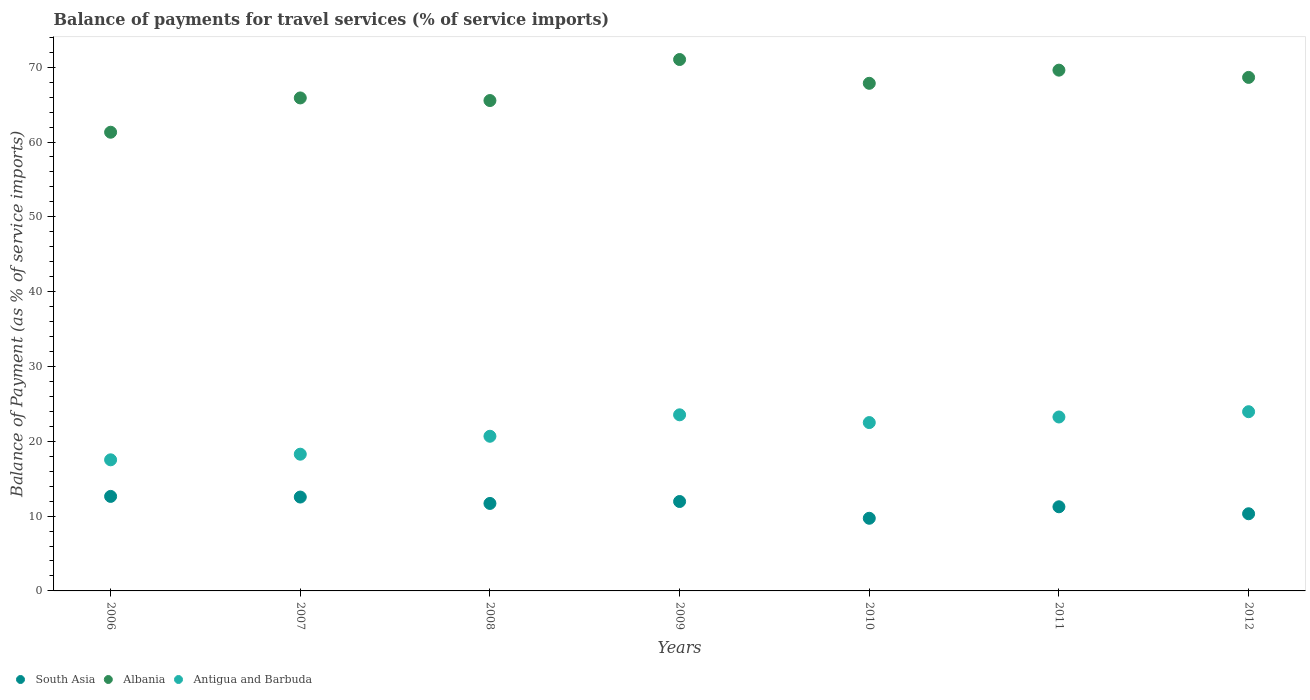How many different coloured dotlines are there?
Give a very brief answer. 3. Is the number of dotlines equal to the number of legend labels?
Your response must be concise. Yes. What is the balance of payments for travel services in Albania in 2008?
Ensure brevity in your answer.  65.54. Across all years, what is the maximum balance of payments for travel services in South Asia?
Give a very brief answer. 12.63. Across all years, what is the minimum balance of payments for travel services in Albania?
Ensure brevity in your answer.  61.31. In which year was the balance of payments for travel services in South Asia maximum?
Your answer should be very brief. 2006. In which year was the balance of payments for travel services in South Asia minimum?
Provide a succinct answer. 2010. What is the total balance of payments for travel services in Albania in the graph?
Provide a succinct answer. 469.87. What is the difference between the balance of payments for travel services in South Asia in 2010 and that in 2012?
Make the answer very short. -0.6. What is the difference between the balance of payments for travel services in South Asia in 2012 and the balance of payments for travel services in Antigua and Barbuda in 2009?
Offer a very short reply. -13.22. What is the average balance of payments for travel services in Antigua and Barbuda per year?
Ensure brevity in your answer.  21.39. In the year 2007, what is the difference between the balance of payments for travel services in Antigua and Barbuda and balance of payments for travel services in South Asia?
Provide a succinct answer. 5.73. In how many years, is the balance of payments for travel services in Albania greater than 66 %?
Provide a short and direct response. 4. What is the ratio of the balance of payments for travel services in Antigua and Barbuda in 2008 to that in 2011?
Provide a succinct answer. 0.89. Is the balance of payments for travel services in Albania in 2009 less than that in 2010?
Give a very brief answer. No. Is the difference between the balance of payments for travel services in Antigua and Barbuda in 2008 and 2012 greater than the difference between the balance of payments for travel services in South Asia in 2008 and 2012?
Ensure brevity in your answer.  No. What is the difference between the highest and the second highest balance of payments for travel services in Antigua and Barbuda?
Ensure brevity in your answer.  0.42. What is the difference between the highest and the lowest balance of payments for travel services in Albania?
Give a very brief answer. 9.72. In how many years, is the balance of payments for travel services in Albania greater than the average balance of payments for travel services in Albania taken over all years?
Your answer should be compact. 4. Is the balance of payments for travel services in South Asia strictly greater than the balance of payments for travel services in Antigua and Barbuda over the years?
Keep it short and to the point. No. Is the balance of payments for travel services in South Asia strictly less than the balance of payments for travel services in Albania over the years?
Offer a very short reply. Yes. How many dotlines are there?
Your answer should be very brief. 3. How many years are there in the graph?
Your response must be concise. 7. What is the difference between two consecutive major ticks on the Y-axis?
Give a very brief answer. 10. Does the graph contain any zero values?
Make the answer very short. No. Does the graph contain grids?
Keep it short and to the point. No. How many legend labels are there?
Offer a very short reply. 3. What is the title of the graph?
Offer a very short reply. Balance of payments for travel services (% of service imports). Does "Saudi Arabia" appear as one of the legend labels in the graph?
Your response must be concise. No. What is the label or title of the Y-axis?
Make the answer very short. Balance of Payment (as % of service imports). What is the Balance of Payment (as % of service imports) of South Asia in 2006?
Offer a terse response. 12.63. What is the Balance of Payment (as % of service imports) in Albania in 2006?
Give a very brief answer. 61.31. What is the Balance of Payment (as % of service imports) in Antigua and Barbuda in 2006?
Provide a short and direct response. 17.52. What is the Balance of Payment (as % of service imports) of South Asia in 2007?
Provide a succinct answer. 12.55. What is the Balance of Payment (as % of service imports) in Albania in 2007?
Ensure brevity in your answer.  65.89. What is the Balance of Payment (as % of service imports) in Antigua and Barbuda in 2007?
Offer a very short reply. 18.27. What is the Balance of Payment (as % of service imports) in South Asia in 2008?
Provide a succinct answer. 11.69. What is the Balance of Payment (as % of service imports) of Albania in 2008?
Give a very brief answer. 65.54. What is the Balance of Payment (as % of service imports) in Antigua and Barbuda in 2008?
Your answer should be very brief. 20.67. What is the Balance of Payment (as % of service imports) in South Asia in 2009?
Your answer should be very brief. 11.95. What is the Balance of Payment (as % of service imports) of Albania in 2009?
Your answer should be compact. 71.03. What is the Balance of Payment (as % of service imports) of Antigua and Barbuda in 2009?
Your answer should be compact. 23.54. What is the Balance of Payment (as % of service imports) of South Asia in 2010?
Provide a succinct answer. 9.71. What is the Balance of Payment (as % of service imports) of Albania in 2010?
Your answer should be very brief. 67.85. What is the Balance of Payment (as % of service imports) in Antigua and Barbuda in 2010?
Your response must be concise. 22.5. What is the Balance of Payment (as % of service imports) in South Asia in 2011?
Offer a very short reply. 11.25. What is the Balance of Payment (as % of service imports) in Albania in 2011?
Provide a succinct answer. 69.61. What is the Balance of Payment (as % of service imports) in Antigua and Barbuda in 2011?
Make the answer very short. 23.25. What is the Balance of Payment (as % of service imports) of South Asia in 2012?
Your answer should be compact. 10.31. What is the Balance of Payment (as % of service imports) in Albania in 2012?
Make the answer very short. 68.64. What is the Balance of Payment (as % of service imports) of Antigua and Barbuda in 2012?
Provide a succinct answer. 23.95. Across all years, what is the maximum Balance of Payment (as % of service imports) in South Asia?
Your answer should be very brief. 12.63. Across all years, what is the maximum Balance of Payment (as % of service imports) in Albania?
Give a very brief answer. 71.03. Across all years, what is the maximum Balance of Payment (as % of service imports) in Antigua and Barbuda?
Your response must be concise. 23.95. Across all years, what is the minimum Balance of Payment (as % of service imports) in South Asia?
Your response must be concise. 9.71. Across all years, what is the minimum Balance of Payment (as % of service imports) of Albania?
Make the answer very short. 61.31. Across all years, what is the minimum Balance of Payment (as % of service imports) in Antigua and Barbuda?
Offer a very short reply. 17.52. What is the total Balance of Payment (as % of service imports) of South Asia in the graph?
Your answer should be compact. 80.1. What is the total Balance of Payment (as % of service imports) of Albania in the graph?
Keep it short and to the point. 469.87. What is the total Balance of Payment (as % of service imports) of Antigua and Barbuda in the graph?
Offer a very short reply. 149.71. What is the difference between the Balance of Payment (as % of service imports) of South Asia in 2006 and that in 2007?
Your answer should be compact. 0.09. What is the difference between the Balance of Payment (as % of service imports) in Albania in 2006 and that in 2007?
Keep it short and to the point. -4.58. What is the difference between the Balance of Payment (as % of service imports) in Antigua and Barbuda in 2006 and that in 2007?
Make the answer very short. -0.75. What is the difference between the Balance of Payment (as % of service imports) of South Asia in 2006 and that in 2008?
Give a very brief answer. 0.94. What is the difference between the Balance of Payment (as % of service imports) in Albania in 2006 and that in 2008?
Provide a short and direct response. -4.24. What is the difference between the Balance of Payment (as % of service imports) in Antigua and Barbuda in 2006 and that in 2008?
Make the answer very short. -3.15. What is the difference between the Balance of Payment (as % of service imports) in South Asia in 2006 and that in 2009?
Your answer should be compact. 0.68. What is the difference between the Balance of Payment (as % of service imports) in Albania in 2006 and that in 2009?
Your answer should be very brief. -9.72. What is the difference between the Balance of Payment (as % of service imports) in Antigua and Barbuda in 2006 and that in 2009?
Make the answer very short. -6.01. What is the difference between the Balance of Payment (as % of service imports) of South Asia in 2006 and that in 2010?
Give a very brief answer. 2.92. What is the difference between the Balance of Payment (as % of service imports) in Albania in 2006 and that in 2010?
Make the answer very short. -6.54. What is the difference between the Balance of Payment (as % of service imports) of Antigua and Barbuda in 2006 and that in 2010?
Keep it short and to the point. -4.98. What is the difference between the Balance of Payment (as % of service imports) in South Asia in 2006 and that in 2011?
Provide a short and direct response. 1.39. What is the difference between the Balance of Payment (as % of service imports) in Albania in 2006 and that in 2011?
Offer a very short reply. -8.3. What is the difference between the Balance of Payment (as % of service imports) of Antigua and Barbuda in 2006 and that in 2011?
Provide a short and direct response. -5.72. What is the difference between the Balance of Payment (as % of service imports) in South Asia in 2006 and that in 2012?
Your answer should be compact. 2.32. What is the difference between the Balance of Payment (as % of service imports) of Albania in 2006 and that in 2012?
Your answer should be compact. -7.33. What is the difference between the Balance of Payment (as % of service imports) in Antigua and Barbuda in 2006 and that in 2012?
Your answer should be compact. -6.43. What is the difference between the Balance of Payment (as % of service imports) of South Asia in 2007 and that in 2008?
Offer a very short reply. 0.85. What is the difference between the Balance of Payment (as % of service imports) of Albania in 2007 and that in 2008?
Offer a very short reply. 0.35. What is the difference between the Balance of Payment (as % of service imports) of Antigua and Barbuda in 2007 and that in 2008?
Provide a short and direct response. -2.4. What is the difference between the Balance of Payment (as % of service imports) in South Asia in 2007 and that in 2009?
Provide a succinct answer. 0.6. What is the difference between the Balance of Payment (as % of service imports) in Albania in 2007 and that in 2009?
Ensure brevity in your answer.  -5.14. What is the difference between the Balance of Payment (as % of service imports) in Antigua and Barbuda in 2007 and that in 2009?
Provide a succinct answer. -5.26. What is the difference between the Balance of Payment (as % of service imports) of South Asia in 2007 and that in 2010?
Ensure brevity in your answer.  2.84. What is the difference between the Balance of Payment (as % of service imports) of Albania in 2007 and that in 2010?
Your answer should be compact. -1.96. What is the difference between the Balance of Payment (as % of service imports) of Antigua and Barbuda in 2007 and that in 2010?
Keep it short and to the point. -4.23. What is the difference between the Balance of Payment (as % of service imports) of South Asia in 2007 and that in 2011?
Offer a very short reply. 1.3. What is the difference between the Balance of Payment (as % of service imports) of Albania in 2007 and that in 2011?
Keep it short and to the point. -3.71. What is the difference between the Balance of Payment (as % of service imports) of Antigua and Barbuda in 2007 and that in 2011?
Give a very brief answer. -4.97. What is the difference between the Balance of Payment (as % of service imports) of South Asia in 2007 and that in 2012?
Provide a succinct answer. 2.23. What is the difference between the Balance of Payment (as % of service imports) of Albania in 2007 and that in 2012?
Your response must be concise. -2.75. What is the difference between the Balance of Payment (as % of service imports) in Antigua and Barbuda in 2007 and that in 2012?
Keep it short and to the point. -5.68. What is the difference between the Balance of Payment (as % of service imports) in South Asia in 2008 and that in 2009?
Offer a very short reply. -0.26. What is the difference between the Balance of Payment (as % of service imports) in Albania in 2008 and that in 2009?
Your answer should be compact. -5.48. What is the difference between the Balance of Payment (as % of service imports) in Antigua and Barbuda in 2008 and that in 2009?
Your answer should be very brief. -2.87. What is the difference between the Balance of Payment (as % of service imports) in South Asia in 2008 and that in 2010?
Keep it short and to the point. 1.98. What is the difference between the Balance of Payment (as % of service imports) in Albania in 2008 and that in 2010?
Give a very brief answer. -2.3. What is the difference between the Balance of Payment (as % of service imports) in Antigua and Barbuda in 2008 and that in 2010?
Make the answer very short. -1.83. What is the difference between the Balance of Payment (as % of service imports) in South Asia in 2008 and that in 2011?
Give a very brief answer. 0.45. What is the difference between the Balance of Payment (as % of service imports) in Albania in 2008 and that in 2011?
Offer a very short reply. -4.06. What is the difference between the Balance of Payment (as % of service imports) in Antigua and Barbuda in 2008 and that in 2011?
Offer a very short reply. -2.58. What is the difference between the Balance of Payment (as % of service imports) of South Asia in 2008 and that in 2012?
Give a very brief answer. 1.38. What is the difference between the Balance of Payment (as % of service imports) in Albania in 2008 and that in 2012?
Give a very brief answer. -3.09. What is the difference between the Balance of Payment (as % of service imports) in Antigua and Barbuda in 2008 and that in 2012?
Your answer should be compact. -3.28. What is the difference between the Balance of Payment (as % of service imports) of South Asia in 2009 and that in 2010?
Your response must be concise. 2.24. What is the difference between the Balance of Payment (as % of service imports) of Albania in 2009 and that in 2010?
Ensure brevity in your answer.  3.18. What is the difference between the Balance of Payment (as % of service imports) in Antigua and Barbuda in 2009 and that in 2010?
Your response must be concise. 1.04. What is the difference between the Balance of Payment (as % of service imports) of South Asia in 2009 and that in 2011?
Provide a succinct answer. 0.71. What is the difference between the Balance of Payment (as % of service imports) in Albania in 2009 and that in 2011?
Keep it short and to the point. 1.42. What is the difference between the Balance of Payment (as % of service imports) of Antigua and Barbuda in 2009 and that in 2011?
Provide a short and direct response. 0.29. What is the difference between the Balance of Payment (as % of service imports) in South Asia in 2009 and that in 2012?
Make the answer very short. 1.64. What is the difference between the Balance of Payment (as % of service imports) in Albania in 2009 and that in 2012?
Offer a very short reply. 2.39. What is the difference between the Balance of Payment (as % of service imports) in Antigua and Barbuda in 2009 and that in 2012?
Provide a short and direct response. -0.42. What is the difference between the Balance of Payment (as % of service imports) in South Asia in 2010 and that in 2011?
Your answer should be very brief. -1.54. What is the difference between the Balance of Payment (as % of service imports) of Albania in 2010 and that in 2011?
Provide a succinct answer. -1.76. What is the difference between the Balance of Payment (as % of service imports) of Antigua and Barbuda in 2010 and that in 2011?
Keep it short and to the point. -0.75. What is the difference between the Balance of Payment (as % of service imports) in South Asia in 2010 and that in 2012?
Your answer should be very brief. -0.6. What is the difference between the Balance of Payment (as % of service imports) of Albania in 2010 and that in 2012?
Provide a short and direct response. -0.79. What is the difference between the Balance of Payment (as % of service imports) of Antigua and Barbuda in 2010 and that in 2012?
Provide a short and direct response. -1.45. What is the difference between the Balance of Payment (as % of service imports) in South Asia in 2011 and that in 2012?
Keep it short and to the point. 0.93. What is the difference between the Balance of Payment (as % of service imports) of Albania in 2011 and that in 2012?
Make the answer very short. 0.97. What is the difference between the Balance of Payment (as % of service imports) in Antigua and Barbuda in 2011 and that in 2012?
Make the answer very short. -0.71. What is the difference between the Balance of Payment (as % of service imports) of South Asia in 2006 and the Balance of Payment (as % of service imports) of Albania in 2007?
Ensure brevity in your answer.  -53.26. What is the difference between the Balance of Payment (as % of service imports) of South Asia in 2006 and the Balance of Payment (as % of service imports) of Antigua and Barbuda in 2007?
Offer a terse response. -5.64. What is the difference between the Balance of Payment (as % of service imports) in Albania in 2006 and the Balance of Payment (as % of service imports) in Antigua and Barbuda in 2007?
Ensure brevity in your answer.  43.03. What is the difference between the Balance of Payment (as % of service imports) in South Asia in 2006 and the Balance of Payment (as % of service imports) in Albania in 2008?
Your answer should be very brief. -52.91. What is the difference between the Balance of Payment (as % of service imports) in South Asia in 2006 and the Balance of Payment (as % of service imports) in Antigua and Barbuda in 2008?
Make the answer very short. -8.04. What is the difference between the Balance of Payment (as % of service imports) of Albania in 2006 and the Balance of Payment (as % of service imports) of Antigua and Barbuda in 2008?
Give a very brief answer. 40.64. What is the difference between the Balance of Payment (as % of service imports) of South Asia in 2006 and the Balance of Payment (as % of service imports) of Albania in 2009?
Offer a terse response. -58.4. What is the difference between the Balance of Payment (as % of service imports) in South Asia in 2006 and the Balance of Payment (as % of service imports) in Antigua and Barbuda in 2009?
Your response must be concise. -10.91. What is the difference between the Balance of Payment (as % of service imports) of Albania in 2006 and the Balance of Payment (as % of service imports) of Antigua and Barbuda in 2009?
Give a very brief answer. 37.77. What is the difference between the Balance of Payment (as % of service imports) in South Asia in 2006 and the Balance of Payment (as % of service imports) in Albania in 2010?
Your answer should be compact. -55.21. What is the difference between the Balance of Payment (as % of service imports) of South Asia in 2006 and the Balance of Payment (as % of service imports) of Antigua and Barbuda in 2010?
Your answer should be very brief. -9.87. What is the difference between the Balance of Payment (as % of service imports) in Albania in 2006 and the Balance of Payment (as % of service imports) in Antigua and Barbuda in 2010?
Give a very brief answer. 38.81. What is the difference between the Balance of Payment (as % of service imports) of South Asia in 2006 and the Balance of Payment (as % of service imports) of Albania in 2011?
Your answer should be compact. -56.97. What is the difference between the Balance of Payment (as % of service imports) of South Asia in 2006 and the Balance of Payment (as % of service imports) of Antigua and Barbuda in 2011?
Your response must be concise. -10.61. What is the difference between the Balance of Payment (as % of service imports) in Albania in 2006 and the Balance of Payment (as % of service imports) in Antigua and Barbuda in 2011?
Offer a very short reply. 38.06. What is the difference between the Balance of Payment (as % of service imports) in South Asia in 2006 and the Balance of Payment (as % of service imports) in Albania in 2012?
Offer a very short reply. -56. What is the difference between the Balance of Payment (as % of service imports) of South Asia in 2006 and the Balance of Payment (as % of service imports) of Antigua and Barbuda in 2012?
Offer a terse response. -11.32. What is the difference between the Balance of Payment (as % of service imports) of Albania in 2006 and the Balance of Payment (as % of service imports) of Antigua and Barbuda in 2012?
Give a very brief answer. 37.35. What is the difference between the Balance of Payment (as % of service imports) in South Asia in 2007 and the Balance of Payment (as % of service imports) in Albania in 2008?
Your answer should be compact. -53. What is the difference between the Balance of Payment (as % of service imports) in South Asia in 2007 and the Balance of Payment (as % of service imports) in Antigua and Barbuda in 2008?
Your answer should be very brief. -8.13. What is the difference between the Balance of Payment (as % of service imports) in Albania in 2007 and the Balance of Payment (as % of service imports) in Antigua and Barbuda in 2008?
Offer a very short reply. 45.22. What is the difference between the Balance of Payment (as % of service imports) of South Asia in 2007 and the Balance of Payment (as % of service imports) of Albania in 2009?
Provide a succinct answer. -58.48. What is the difference between the Balance of Payment (as % of service imports) in South Asia in 2007 and the Balance of Payment (as % of service imports) in Antigua and Barbuda in 2009?
Your answer should be very brief. -10.99. What is the difference between the Balance of Payment (as % of service imports) of Albania in 2007 and the Balance of Payment (as % of service imports) of Antigua and Barbuda in 2009?
Offer a very short reply. 42.35. What is the difference between the Balance of Payment (as % of service imports) of South Asia in 2007 and the Balance of Payment (as % of service imports) of Albania in 2010?
Your response must be concise. -55.3. What is the difference between the Balance of Payment (as % of service imports) of South Asia in 2007 and the Balance of Payment (as % of service imports) of Antigua and Barbuda in 2010?
Ensure brevity in your answer.  -9.95. What is the difference between the Balance of Payment (as % of service imports) of Albania in 2007 and the Balance of Payment (as % of service imports) of Antigua and Barbuda in 2010?
Your answer should be compact. 43.39. What is the difference between the Balance of Payment (as % of service imports) of South Asia in 2007 and the Balance of Payment (as % of service imports) of Albania in 2011?
Offer a terse response. -57.06. What is the difference between the Balance of Payment (as % of service imports) in South Asia in 2007 and the Balance of Payment (as % of service imports) in Antigua and Barbuda in 2011?
Give a very brief answer. -10.7. What is the difference between the Balance of Payment (as % of service imports) of Albania in 2007 and the Balance of Payment (as % of service imports) of Antigua and Barbuda in 2011?
Provide a short and direct response. 42.64. What is the difference between the Balance of Payment (as % of service imports) of South Asia in 2007 and the Balance of Payment (as % of service imports) of Albania in 2012?
Keep it short and to the point. -56.09. What is the difference between the Balance of Payment (as % of service imports) in South Asia in 2007 and the Balance of Payment (as % of service imports) in Antigua and Barbuda in 2012?
Your response must be concise. -11.41. What is the difference between the Balance of Payment (as % of service imports) in Albania in 2007 and the Balance of Payment (as % of service imports) in Antigua and Barbuda in 2012?
Provide a succinct answer. 41.94. What is the difference between the Balance of Payment (as % of service imports) in South Asia in 2008 and the Balance of Payment (as % of service imports) in Albania in 2009?
Give a very brief answer. -59.34. What is the difference between the Balance of Payment (as % of service imports) of South Asia in 2008 and the Balance of Payment (as % of service imports) of Antigua and Barbuda in 2009?
Your response must be concise. -11.85. What is the difference between the Balance of Payment (as % of service imports) in Albania in 2008 and the Balance of Payment (as % of service imports) in Antigua and Barbuda in 2009?
Your answer should be compact. 42.01. What is the difference between the Balance of Payment (as % of service imports) of South Asia in 2008 and the Balance of Payment (as % of service imports) of Albania in 2010?
Provide a short and direct response. -56.15. What is the difference between the Balance of Payment (as % of service imports) in South Asia in 2008 and the Balance of Payment (as % of service imports) in Antigua and Barbuda in 2010?
Keep it short and to the point. -10.81. What is the difference between the Balance of Payment (as % of service imports) in Albania in 2008 and the Balance of Payment (as % of service imports) in Antigua and Barbuda in 2010?
Your answer should be compact. 43.04. What is the difference between the Balance of Payment (as % of service imports) in South Asia in 2008 and the Balance of Payment (as % of service imports) in Albania in 2011?
Your answer should be compact. -57.91. What is the difference between the Balance of Payment (as % of service imports) in South Asia in 2008 and the Balance of Payment (as % of service imports) in Antigua and Barbuda in 2011?
Your answer should be compact. -11.55. What is the difference between the Balance of Payment (as % of service imports) in Albania in 2008 and the Balance of Payment (as % of service imports) in Antigua and Barbuda in 2011?
Provide a short and direct response. 42.3. What is the difference between the Balance of Payment (as % of service imports) in South Asia in 2008 and the Balance of Payment (as % of service imports) in Albania in 2012?
Provide a succinct answer. -56.94. What is the difference between the Balance of Payment (as % of service imports) of South Asia in 2008 and the Balance of Payment (as % of service imports) of Antigua and Barbuda in 2012?
Your response must be concise. -12.26. What is the difference between the Balance of Payment (as % of service imports) of Albania in 2008 and the Balance of Payment (as % of service imports) of Antigua and Barbuda in 2012?
Provide a succinct answer. 41.59. What is the difference between the Balance of Payment (as % of service imports) in South Asia in 2009 and the Balance of Payment (as % of service imports) in Albania in 2010?
Offer a very short reply. -55.9. What is the difference between the Balance of Payment (as % of service imports) in South Asia in 2009 and the Balance of Payment (as % of service imports) in Antigua and Barbuda in 2010?
Your response must be concise. -10.55. What is the difference between the Balance of Payment (as % of service imports) in Albania in 2009 and the Balance of Payment (as % of service imports) in Antigua and Barbuda in 2010?
Your response must be concise. 48.53. What is the difference between the Balance of Payment (as % of service imports) of South Asia in 2009 and the Balance of Payment (as % of service imports) of Albania in 2011?
Offer a terse response. -57.65. What is the difference between the Balance of Payment (as % of service imports) in South Asia in 2009 and the Balance of Payment (as % of service imports) in Antigua and Barbuda in 2011?
Ensure brevity in your answer.  -11.3. What is the difference between the Balance of Payment (as % of service imports) of Albania in 2009 and the Balance of Payment (as % of service imports) of Antigua and Barbuda in 2011?
Offer a very short reply. 47.78. What is the difference between the Balance of Payment (as % of service imports) of South Asia in 2009 and the Balance of Payment (as % of service imports) of Albania in 2012?
Give a very brief answer. -56.69. What is the difference between the Balance of Payment (as % of service imports) of South Asia in 2009 and the Balance of Payment (as % of service imports) of Antigua and Barbuda in 2012?
Keep it short and to the point. -12. What is the difference between the Balance of Payment (as % of service imports) of Albania in 2009 and the Balance of Payment (as % of service imports) of Antigua and Barbuda in 2012?
Make the answer very short. 47.07. What is the difference between the Balance of Payment (as % of service imports) of South Asia in 2010 and the Balance of Payment (as % of service imports) of Albania in 2011?
Ensure brevity in your answer.  -59.9. What is the difference between the Balance of Payment (as % of service imports) of South Asia in 2010 and the Balance of Payment (as % of service imports) of Antigua and Barbuda in 2011?
Give a very brief answer. -13.54. What is the difference between the Balance of Payment (as % of service imports) of Albania in 2010 and the Balance of Payment (as % of service imports) of Antigua and Barbuda in 2011?
Provide a succinct answer. 44.6. What is the difference between the Balance of Payment (as % of service imports) of South Asia in 2010 and the Balance of Payment (as % of service imports) of Albania in 2012?
Keep it short and to the point. -58.93. What is the difference between the Balance of Payment (as % of service imports) in South Asia in 2010 and the Balance of Payment (as % of service imports) in Antigua and Barbuda in 2012?
Offer a very short reply. -14.24. What is the difference between the Balance of Payment (as % of service imports) in Albania in 2010 and the Balance of Payment (as % of service imports) in Antigua and Barbuda in 2012?
Offer a terse response. 43.89. What is the difference between the Balance of Payment (as % of service imports) of South Asia in 2011 and the Balance of Payment (as % of service imports) of Albania in 2012?
Provide a succinct answer. -57.39. What is the difference between the Balance of Payment (as % of service imports) in South Asia in 2011 and the Balance of Payment (as % of service imports) in Antigua and Barbuda in 2012?
Provide a short and direct response. -12.71. What is the difference between the Balance of Payment (as % of service imports) of Albania in 2011 and the Balance of Payment (as % of service imports) of Antigua and Barbuda in 2012?
Ensure brevity in your answer.  45.65. What is the average Balance of Payment (as % of service imports) of South Asia per year?
Offer a terse response. 11.44. What is the average Balance of Payment (as % of service imports) of Albania per year?
Make the answer very short. 67.12. What is the average Balance of Payment (as % of service imports) in Antigua and Barbuda per year?
Provide a succinct answer. 21.39. In the year 2006, what is the difference between the Balance of Payment (as % of service imports) in South Asia and Balance of Payment (as % of service imports) in Albania?
Offer a very short reply. -48.68. In the year 2006, what is the difference between the Balance of Payment (as % of service imports) in South Asia and Balance of Payment (as % of service imports) in Antigua and Barbuda?
Your response must be concise. -4.89. In the year 2006, what is the difference between the Balance of Payment (as % of service imports) in Albania and Balance of Payment (as % of service imports) in Antigua and Barbuda?
Your answer should be very brief. 43.78. In the year 2007, what is the difference between the Balance of Payment (as % of service imports) in South Asia and Balance of Payment (as % of service imports) in Albania?
Ensure brevity in your answer.  -53.35. In the year 2007, what is the difference between the Balance of Payment (as % of service imports) in South Asia and Balance of Payment (as % of service imports) in Antigua and Barbuda?
Give a very brief answer. -5.73. In the year 2007, what is the difference between the Balance of Payment (as % of service imports) in Albania and Balance of Payment (as % of service imports) in Antigua and Barbuda?
Provide a succinct answer. 47.62. In the year 2008, what is the difference between the Balance of Payment (as % of service imports) of South Asia and Balance of Payment (as % of service imports) of Albania?
Your response must be concise. -53.85. In the year 2008, what is the difference between the Balance of Payment (as % of service imports) in South Asia and Balance of Payment (as % of service imports) in Antigua and Barbuda?
Offer a very short reply. -8.98. In the year 2008, what is the difference between the Balance of Payment (as % of service imports) of Albania and Balance of Payment (as % of service imports) of Antigua and Barbuda?
Give a very brief answer. 44.87. In the year 2009, what is the difference between the Balance of Payment (as % of service imports) in South Asia and Balance of Payment (as % of service imports) in Albania?
Provide a short and direct response. -59.08. In the year 2009, what is the difference between the Balance of Payment (as % of service imports) in South Asia and Balance of Payment (as % of service imports) in Antigua and Barbuda?
Your response must be concise. -11.59. In the year 2009, what is the difference between the Balance of Payment (as % of service imports) in Albania and Balance of Payment (as % of service imports) in Antigua and Barbuda?
Provide a short and direct response. 47.49. In the year 2010, what is the difference between the Balance of Payment (as % of service imports) of South Asia and Balance of Payment (as % of service imports) of Albania?
Keep it short and to the point. -58.14. In the year 2010, what is the difference between the Balance of Payment (as % of service imports) in South Asia and Balance of Payment (as % of service imports) in Antigua and Barbuda?
Offer a terse response. -12.79. In the year 2010, what is the difference between the Balance of Payment (as % of service imports) in Albania and Balance of Payment (as % of service imports) in Antigua and Barbuda?
Your answer should be compact. 45.35. In the year 2011, what is the difference between the Balance of Payment (as % of service imports) of South Asia and Balance of Payment (as % of service imports) of Albania?
Ensure brevity in your answer.  -58.36. In the year 2011, what is the difference between the Balance of Payment (as % of service imports) of South Asia and Balance of Payment (as % of service imports) of Antigua and Barbuda?
Your answer should be very brief. -12. In the year 2011, what is the difference between the Balance of Payment (as % of service imports) of Albania and Balance of Payment (as % of service imports) of Antigua and Barbuda?
Offer a terse response. 46.36. In the year 2012, what is the difference between the Balance of Payment (as % of service imports) in South Asia and Balance of Payment (as % of service imports) in Albania?
Offer a terse response. -58.32. In the year 2012, what is the difference between the Balance of Payment (as % of service imports) of South Asia and Balance of Payment (as % of service imports) of Antigua and Barbuda?
Provide a succinct answer. -13.64. In the year 2012, what is the difference between the Balance of Payment (as % of service imports) in Albania and Balance of Payment (as % of service imports) in Antigua and Barbuda?
Make the answer very short. 44.68. What is the ratio of the Balance of Payment (as % of service imports) in South Asia in 2006 to that in 2007?
Your answer should be compact. 1.01. What is the ratio of the Balance of Payment (as % of service imports) in Albania in 2006 to that in 2007?
Offer a terse response. 0.93. What is the ratio of the Balance of Payment (as % of service imports) in Antigua and Barbuda in 2006 to that in 2007?
Provide a short and direct response. 0.96. What is the ratio of the Balance of Payment (as % of service imports) in South Asia in 2006 to that in 2008?
Make the answer very short. 1.08. What is the ratio of the Balance of Payment (as % of service imports) in Albania in 2006 to that in 2008?
Give a very brief answer. 0.94. What is the ratio of the Balance of Payment (as % of service imports) in Antigua and Barbuda in 2006 to that in 2008?
Your response must be concise. 0.85. What is the ratio of the Balance of Payment (as % of service imports) in South Asia in 2006 to that in 2009?
Provide a short and direct response. 1.06. What is the ratio of the Balance of Payment (as % of service imports) of Albania in 2006 to that in 2009?
Provide a succinct answer. 0.86. What is the ratio of the Balance of Payment (as % of service imports) of Antigua and Barbuda in 2006 to that in 2009?
Give a very brief answer. 0.74. What is the ratio of the Balance of Payment (as % of service imports) of South Asia in 2006 to that in 2010?
Make the answer very short. 1.3. What is the ratio of the Balance of Payment (as % of service imports) of Albania in 2006 to that in 2010?
Your response must be concise. 0.9. What is the ratio of the Balance of Payment (as % of service imports) in Antigua and Barbuda in 2006 to that in 2010?
Provide a short and direct response. 0.78. What is the ratio of the Balance of Payment (as % of service imports) in South Asia in 2006 to that in 2011?
Keep it short and to the point. 1.12. What is the ratio of the Balance of Payment (as % of service imports) in Albania in 2006 to that in 2011?
Provide a short and direct response. 0.88. What is the ratio of the Balance of Payment (as % of service imports) in Antigua and Barbuda in 2006 to that in 2011?
Your answer should be compact. 0.75. What is the ratio of the Balance of Payment (as % of service imports) in South Asia in 2006 to that in 2012?
Provide a succinct answer. 1.22. What is the ratio of the Balance of Payment (as % of service imports) in Albania in 2006 to that in 2012?
Ensure brevity in your answer.  0.89. What is the ratio of the Balance of Payment (as % of service imports) of Antigua and Barbuda in 2006 to that in 2012?
Make the answer very short. 0.73. What is the ratio of the Balance of Payment (as % of service imports) in South Asia in 2007 to that in 2008?
Provide a succinct answer. 1.07. What is the ratio of the Balance of Payment (as % of service imports) of Antigua and Barbuda in 2007 to that in 2008?
Make the answer very short. 0.88. What is the ratio of the Balance of Payment (as % of service imports) of South Asia in 2007 to that in 2009?
Give a very brief answer. 1.05. What is the ratio of the Balance of Payment (as % of service imports) of Albania in 2007 to that in 2009?
Your answer should be very brief. 0.93. What is the ratio of the Balance of Payment (as % of service imports) in Antigua and Barbuda in 2007 to that in 2009?
Give a very brief answer. 0.78. What is the ratio of the Balance of Payment (as % of service imports) in South Asia in 2007 to that in 2010?
Provide a short and direct response. 1.29. What is the ratio of the Balance of Payment (as % of service imports) of Albania in 2007 to that in 2010?
Offer a very short reply. 0.97. What is the ratio of the Balance of Payment (as % of service imports) of Antigua and Barbuda in 2007 to that in 2010?
Make the answer very short. 0.81. What is the ratio of the Balance of Payment (as % of service imports) in South Asia in 2007 to that in 2011?
Your response must be concise. 1.12. What is the ratio of the Balance of Payment (as % of service imports) of Albania in 2007 to that in 2011?
Your answer should be compact. 0.95. What is the ratio of the Balance of Payment (as % of service imports) in Antigua and Barbuda in 2007 to that in 2011?
Offer a terse response. 0.79. What is the ratio of the Balance of Payment (as % of service imports) in South Asia in 2007 to that in 2012?
Ensure brevity in your answer.  1.22. What is the ratio of the Balance of Payment (as % of service imports) of Antigua and Barbuda in 2007 to that in 2012?
Offer a terse response. 0.76. What is the ratio of the Balance of Payment (as % of service imports) in South Asia in 2008 to that in 2009?
Give a very brief answer. 0.98. What is the ratio of the Balance of Payment (as % of service imports) of Albania in 2008 to that in 2009?
Make the answer very short. 0.92. What is the ratio of the Balance of Payment (as % of service imports) of Antigua and Barbuda in 2008 to that in 2009?
Your answer should be compact. 0.88. What is the ratio of the Balance of Payment (as % of service imports) in South Asia in 2008 to that in 2010?
Make the answer very short. 1.2. What is the ratio of the Balance of Payment (as % of service imports) in Albania in 2008 to that in 2010?
Your answer should be very brief. 0.97. What is the ratio of the Balance of Payment (as % of service imports) in Antigua and Barbuda in 2008 to that in 2010?
Provide a succinct answer. 0.92. What is the ratio of the Balance of Payment (as % of service imports) of South Asia in 2008 to that in 2011?
Give a very brief answer. 1.04. What is the ratio of the Balance of Payment (as % of service imports) of Albania in 2008 to that in 2011?
Provide a short and direct response. 0.94. What is the ratio of the Balance of Payment (as % of service imports) in Antigua and Barbuda in 2008 to that in 2011?
Keep it short and to the point. 0.89. What is the ratio of the Balance of Payment (as % of service imports) in South Asia in 2008 to that in 2012?
Offer a very short reply. 1.13. What is the ratio of the Balance of Payment (as % of service imports) in Albania in 2008 to that in 2012?
Offer a very short reply. 0.95. What is the ratio of the Balance of Payment (as % of service imports) of Antigua and Barbuda in 2008 to that in 2012?
Your response must be concise. 0.86. What is the ratio of the Balance of Payment (as % of service imports) of South Asia in 2009 to that in 2010?
Your response must be concise. 1.23. What is the ratio of the Balance of Payment (as % of service imports) in Albania in 2009 to that in 2010?
Provide a succinct answer. 1.05. What is the ratio of the Balance of Payment (as % of service imports) of Antigua and Barbuda in 2009 to that in 2010?
Ensure brevity in your answer.  1.05. What is the ratio of the Balance of Payment (as % of service imports) of South Asia in 2009 to that in 2011?
Keep it short and to the point. 1.06. What is the ratio of the Balance of Payment (as % of service imports) of Albania in 2009 to that in 2011?
Provide a succinct answer. 1.02. What is the ratio of the Balance of Payment (as % of service imports) in Antigua and Barbuda in 2009 to that in 2011?
Provide a short and direct response. 1.01. What is the ratio of the Balance of Payment (as % of service imports) in South Asia in 2009 to that in 2012?
Provide a succinct answer. 1.16. What is the ratio of the Balance of Payment (as % of service imports) of Albania in 2009 to that in 2012?
Your response must be concise. 1.03. What is the ratio of the Balance of Payment (as % of service imports) in Antigua and Barbuda in 2009 to that in 2012?
Provide a short and direct response. 0.98. What is the ratio of the Balance of Payment (as % of service imports) in South Asia in 2010 to that in 2011?
Keep it short and to the point. 0.86. What is the ratio of the Balance of Payment (as % of service imports) of Albania in 2010 to that in 2011?
Your answer should be compact. 0.97. What is the ratio of the Balance of Payment (as % of service imports) in Antigua and Barbuda in 2010 to that in 2011?
Your answer should be very brief. 0.97. What is the ratio of the Balance of Payment (as % of service imports) in South Asia in 2010 to that in 2012?
Offer a very short reply. 0.94. What is the ratio of the Balance of Payment (as % of service imports) in Antigua and Barbuda in 2010 to that in 2012?
Offer a terse response. 0.94. What is the ratio of the Balance of Payment (as % of service imports) of South Asia in 2011 to that in 2012?
Provide a succinct answer. 1.09. What is the ratio of the Balance of Payment (as % of service imports) in Albania in 2011 to that in 2012?
Offer a very short reply. 1.01. What is the ratio of the Balance of Payment (as % of service imports) in Antigua and Barbuda in 2011 to that in 2012?
Provide a short and direct response. 0.97. What is the difference between the highest and the second highest Balance of Payment (as % of service imports) of South Asia?
Offer a terse response. 0.09. What is the difference between the highest and the second highest Balance of Payment (as % of service imports) in Albania?
Offer a very short reply. 1.42. What is the difference between the highest and the second highest Balance of Payment (as % of service imports) of Antigua and Barbuda?
Your answer should be very brief. 0.42. What is the difference between the highest and the lowest Balance of Payment (as % of service imports) in South Asia?
Keep it short and to the point. 2.92. What is the difference between the highest and the lowest Balance of Payment (as % of service imports) in Albania?
Ensure brevity in your answer.  9.72. What is the difference between the highest and the lowest Balance of Payment (as % of service imports) of Antigua and Barbuda?
Keep it short and to the point. 6.43. 